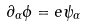<formula> <loc_0><loc_0><loc_500><loc_500>\partial _ { \alpha } \phi = e \psi _ { \alpha }</formula> 